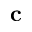Convert formula to latex. <formula><loc_0><loc_0><loc_500><loc_500>c</formula> 